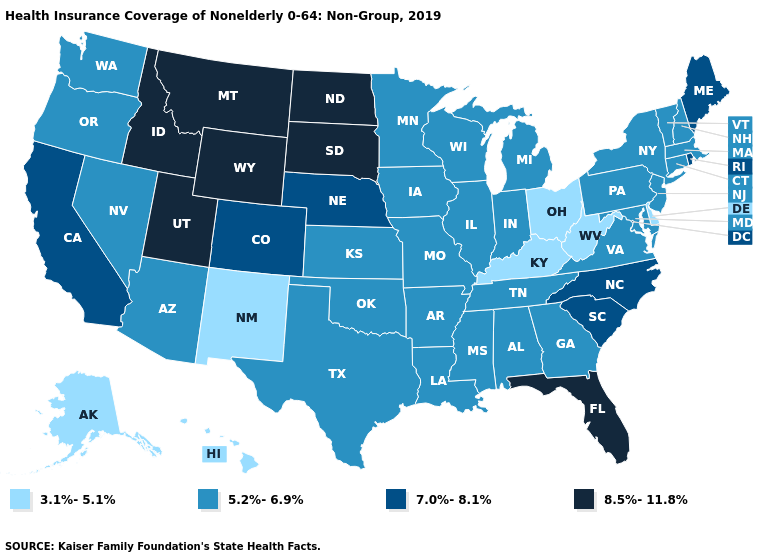What is the value of Illinois?
Write a very short answer. 5.2%-6.9%. Name the states that have a value in the range 8.5%-11.8%?
Quick response, please. Florida, Idaho, Montana, North Dakota, South Dakota, Utah, Wyoming. Does the first symbol in the legend represent the smallest category?
Be succinct. Yes. Which states have the highest value in the USA?
Answer briefly. Florida, Idaho, Montana, North Dakota, South Dakota, Utah, Wyoming. What is the value of Nevada?
Give a very brief answer. 5.2%-6.9%. What is the highest value in the Northeast ?
Be succinct. 7.0%-8.1%. What is the value of Mississippi?
Be succinct. 5.2%-6.9%. Which states have the lowest value in the West?
Short answer required. Alaska, Hawaii, New Mexico. Name the states that have a value in the range 8.5%-11.8%?
Keep it brief. Florida, Idaho, Montana, North Dakota, South Dakota, Utah, Wyoming. What is the value of Idaho?
Keep it brief. 8.5%-11.8%. What is the highest value in the Northeast ?
Concise answer only. 7.0%-8.1%. Name the states that have a value in the range 3.1%-5.1%?
Short answer required. Alaska, Delaware, Hawaii, Kentucky, New Mexico, Ohio, West Virginia. What is the highest value in states that border Idaho?
Answer briefly. 8.5%-11.8%. Does Missouri have a lower value than Delaware?
Short answer required. No. Among the states that border New Mexico , does Utah have the highest value?
Keep it brief. Yes. 